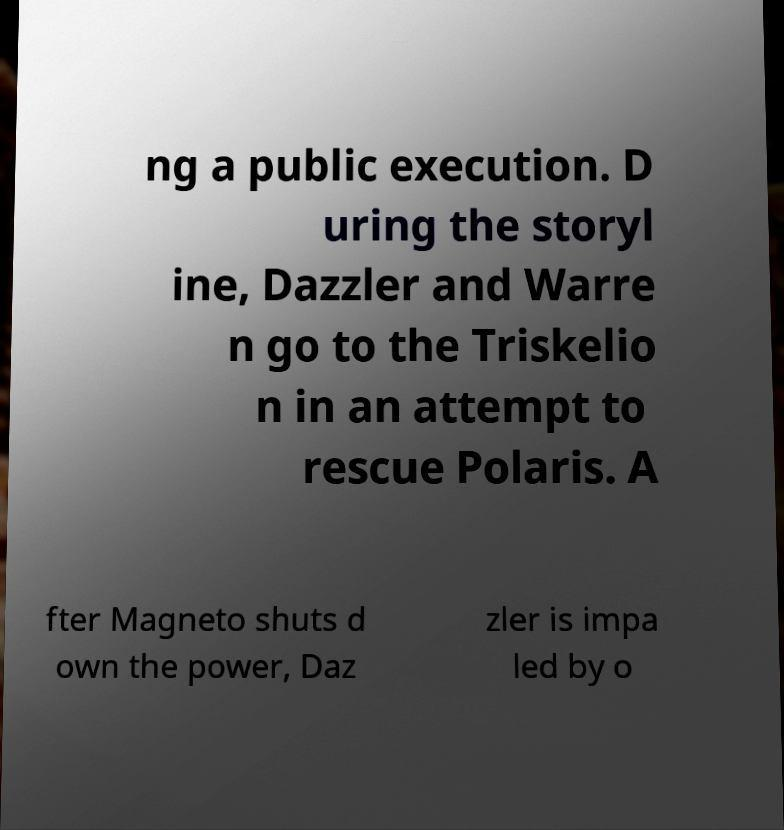Could you assist in decoding the text presented in this image and type it out clearly? ng a public execution. D uring the storyl ine, Dazzler and Warre n go to the Triskelio n in an attempt to rescue Polaris. A fter Magneto shuts d own the power, Daz zler is impa led by o 